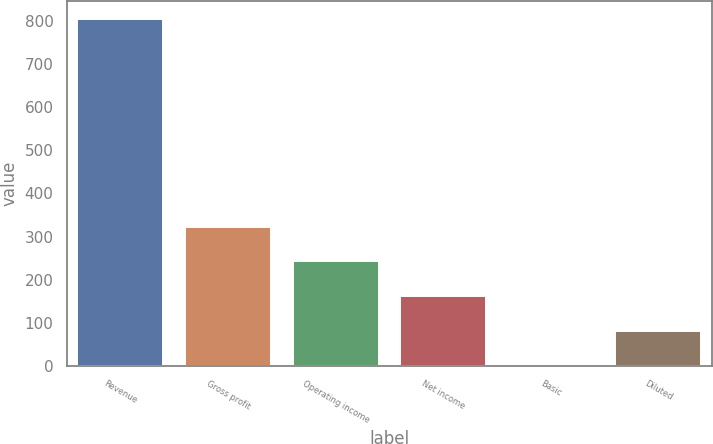<chart> <loc_0><loc_0><loc_500><loc_500><bar_chart><fcel>Revenue<fcel>Gross profit<fcel>Operating income<fcel>Net income<fcel>Basic<fcel>Diluted<nl><fcel>806<fcel>322.69<fcel>242.14<fcel>161.59<fcel>0.49<fcel>81.04<nl></chart> 